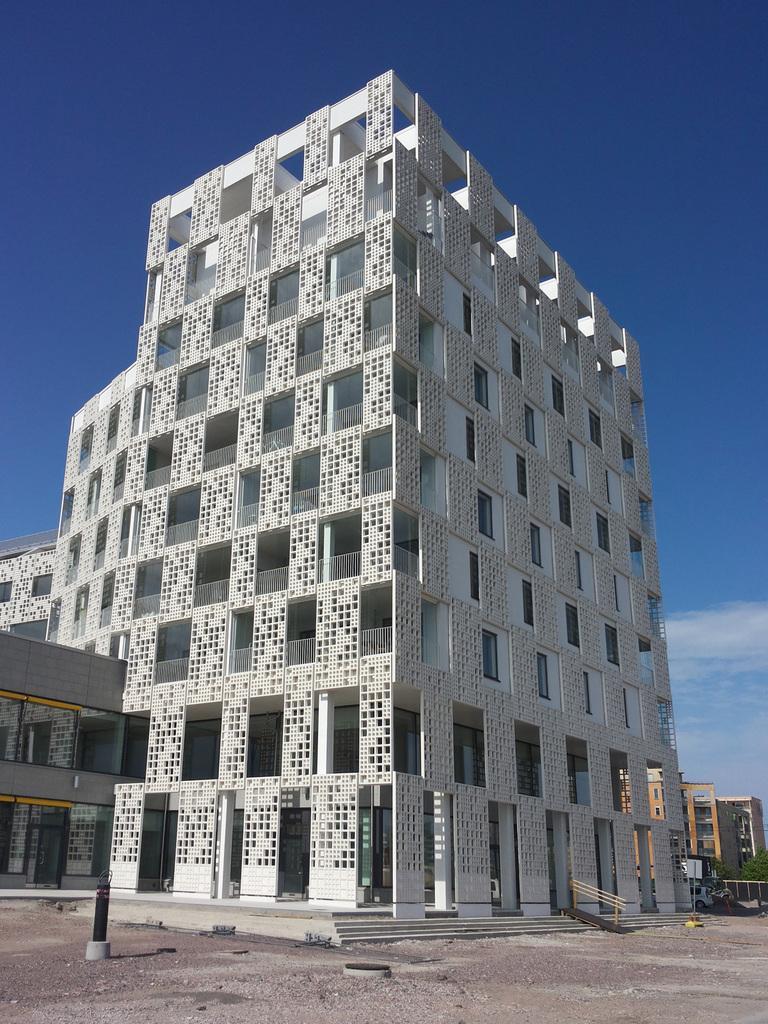In one or two sentences, can you explain what this image depicts? In this image we can see building with group of windows , staircase , railing. In the foreground we can see a pole. In the background, we can see group of buildings, trees and the cloudy sky. 